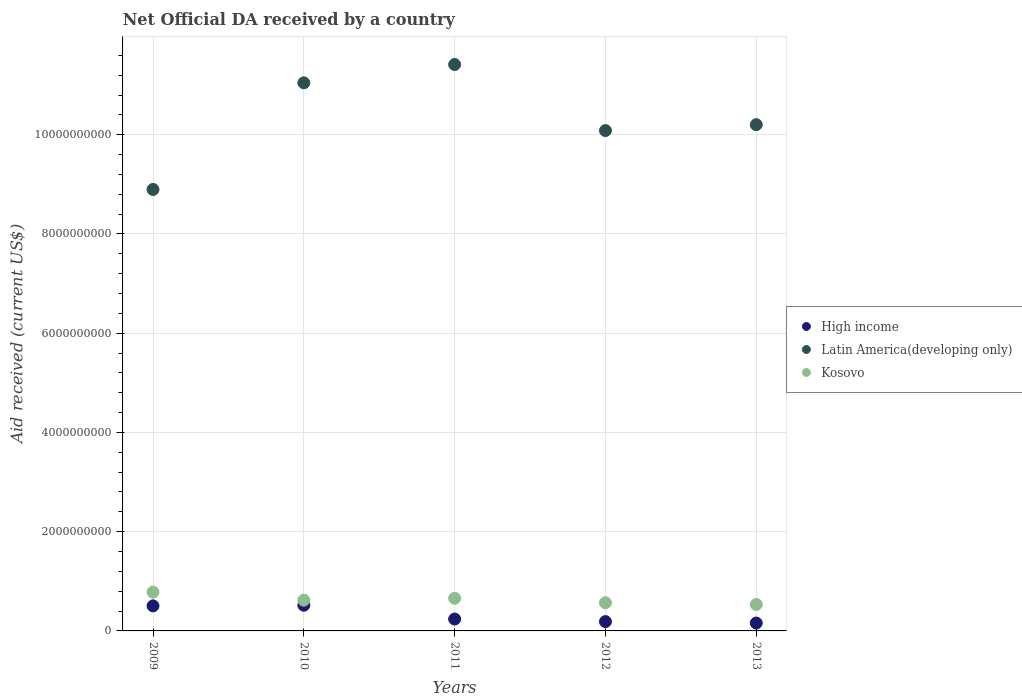Is the number of dotlines equal to the number of legend labels?
Keep it short and to the point. Yes. What is the net official development assistance aid received in Kosovo in 2011?
Provide a short and direct response. 6.57e+08. Across all years, what is the maximum net official development assistance aid received in Kosovo?
Provide a succinct answer. 7.82e+08. Across all years, what is the minimum net official development assistance aid received in High income?
Offer a very short reply. 1.59e+08. In which year was the net official development assistance aid received in Kosovo minimum?
Your response must be concise. 2013. What is the total net official development assistance aid received in Kosovo in the graph?
Ensure brevity in your answer.  3.16e+09. What is the difference between the net official development assistance aid received in High income in 2010 and that in 2013?
Keep it short and to the point. 3.59e+08. What is the difference between the net official development assistance aid received in High income in 2011 and the net official development assistance aid received in Latin America(developing only) in 2013?
Provide a short and direct response. -9.96e+09. What is the average net official development assistance aid received in Latin America(developing only) per year?
Provide a short and direct response. 1.03e+1. In the year 2011, what is the difference between the net official development assistance aid received in Latin America(developing only) and net official development assistance aid received in High income?
Make the answer very short. 1.12e+1. In how many years, is the net official development assistance aid received in High income greater than 5200000000 US$?
Ensure brevity in your answer.  0. What is the ratio of the net official development assistance aid received in Kosovo in 2012 to that in 2013?
Provide a short and direct response. 1.06. Is the difference between the net official development assistance aid received in Latin America(developing only) in 2010 and 2013 greater than the difference between the net official development assistance aid received in High income in 2010 and 2013?
Provide a succinct answer. Yes. What is the difference between the highest and the second highest net official development assistance aid received in Latin America(developing only)?
Give a very brief answer. 3.69e+08. What is the difference between the highest and the lowest net official development assistance aid received in Kosovo?
Ensure brevity in your answer.  2.49e+08. Is the net official development assistance aid received in Kosovo strictly greater than the net official development assistance aid received in High income over the years?
Keep it short and to the point. Yes. Is the net official development assistance aid received in High income strictly less than the net official development assistance aid received in Latin America(developing only) over the years?
Keep it short and to the point. Yes. How many dotlines are there?
Offer a terse response. 3. How many years are there in the graph?
Your answer should be very brief. 5. Are the values on the major ticks of Y-axis written in scientific E-notation?
Provide a succinct answer. No. Does the graph contain any zero values?
Give a very brief answer. No. Does the graph contain grids?
Make the answer very short. Yes. What is the title of the graph?
Provide a short and direct response. Net Official DA received by a country. What is the label or title of the Y-axis?
Your response must be concise. Aid received (current US$). What is the Aid received (current US$) of High income in 2009?
Keep it short and to the point. 5.05e+08. What is the Aid received (current US$) of Latin America(developing only) in 2009?
Your response must be concise. 8.90e+09. What is the Aid received (current US$) of Kosovo in 2009?
Your response must be concise. 7.82e+08. What is the Aid received (current US$) in High income in 2010?
Offer a very short reply. 5.17e+08. What is the Aid received (current US$) in Latin America(developing only) in 2010?
Offer a very short reply. 1.10e+1. What is the Aid received (current US$) of Kosovo in 2010?
Your response must be concise. 6.20e+08. What is the Aid received (current US$) in High income in 2011?
Your answer should be very brief. 2.39e+08. What is the Aid received (current US$) of Latin America(developing only) in 2011?
Keep it short and to the point. 1.14e+1. What is the Aid received (current US$) in Kosovo in 2011?
Your response must be concise. 6.57e+08. What is the Aid received (current US$) in High income in 2012?
Offer a terse response. 1.88e+08. What is the Aid received (current US$) in Latin America(developing only) in 2012?
Ensure brevity in your answer.  1.01e+1. What is the Aid received (current US$) of Kosovo in 2012?
Give a very brief answer. 5.68e+08. What is the Aid received (current US$) of High income in 2013?
Offer a terse response. 1.59e+08. What is the Aid received (current US$) of Latin America(developing only) in 2013?
Offer a very short reply. 1.02e+1. What is the Aid received (current US$) in Kosovo in 2013?
Keep it short and to the point. 5.33e+08. Across all years, what is the maximum Aid received (current US$) of High income?
Your response must be concise. 5.17e+08. Across all years, what is the maximum Aid received (current US$) in Latin America(developing only)?
Provide a short and direct response. 1.14e+1. Across all years, what is the maximum Aid received (current US$) of Kosovo?
Offer a terse response. 7.82e+08. Across all years, what is the minimum Aid received (current US$) in High income?
Provide a short and direct response. 1.59e+08. Across all years, what is the minimum Aid received (current US$) of Latin America(developing only)?
Your answer should be very brief. 8.90e+09. Across all years, what is the minimum Aid received (current US$) in Kosovo?
Keep it short and to the point. 5.33e+08. What is the total Aid received (current US$) of High income in the graph?
Offer a terse response. 1.61e+09. What is the total Aid received (current US$) of Latin America(developing only) in the graph?
Ensure brevity in your answer.  5.16e+1. What is the total Aid received (current US$) of Kosovo in the graph?
Keep it short and to the point. 3.16e+09. What is the difference between the Aid received (current US$) of High income in 2009 and that in 2010?
Your answer should be very brief. -1.27e+07. What is the difference between the Aid received (current US$) of Latin America(developing only) in 2009 and that in 2010?
Give a very brief answer. -2.15e+09. What is the difference between the Aid received (current US$) in Kosovo in 2009 and that in 2010?
Keep it short and to the point. 1.62e+08. What is the difference between the Aid received (current US$) in High income in 2009 and that in 2011?
Your answer should be very brief. 2.65e+08. What is the difference between the Aid received (current US$) of Latin America(developing only) in 2009 and that in 2011?
Offer a terse response. -2.52e+09. What is the difference between the Aid received (current US$) of Kosovo in 2009 and that in 2011?
Your response must be concise. 1.25e+08. What is the difference between the Aid received (current US$) of High income in 2009 and that in 2012?
Keep it short and to the point. 3.17e+08. What is the difference between the Aid received (current US$) of Latin America(developing only) in 2009 and that in 2012?
Your answer should be very brief. -1.19e+09. What is the difference between the Aid received (current US$) of Kosovo in 2009 and that in 2012?
Offer a terse response. 2.14e+08. What is the difference between the Aid received (current US$) in High income in 2009 and that in 2013?
Your response must be concise. 3.46e+08. What is the difference between the Aid received (current US$) of Latin America(developing only) in 2009 and that in 2013?
Offer a terse response. -1.31e+09. What is the difference between the Aid received (current US$) of Kosovo in 2009 and that in 2013?
Ensure brevity in your answer.  2.49e+08. What is the difference between the Aid received (current US$) in High income in 2010 and that in 2011?
Your answer should be very brief. 2.78e+08. What is the difference between the Aid received (current US$) of Latin America(developing only) in 2010 and that in 2011?
Provide a short and direct response. -3.69e+08. What is the difference between the Aid received (current US$) in Kosovo in 2010 and that in 2011?
Keep it short and to the point. -3.72e+07. What is the difference between the Aid received (current US$) of High income in 2010 and that in 2012?
Provide a short and direct response. 3.30e+08. What is the difference between the Aid received (current US$) of Latin America(developing only) in 2010 and that in 2012?
Your response must be concise. 9.62e+08. What is the difference between the Aid received (current US$) of Kosovo in 2010 and that in 2012?
Provide a succinct answer. 5.22e+07. What is the difference between the Aid received (current US$) of High income in 2010 and that in 2013?
Your answer should be compact. 3.59e+08. What is the difference between the Aid received (current US$) in Latin America(developing only) in 2010 and that in 2013?
Your answer should be very brief. 8.44e+08. What is the difference between the Aid received (current US$) of Kosovo in 2010 and that in 2013?
Your answer should be very brief. 8.68e+07. What is the difference between the Aid received (current US$) in High income in 2011 and that in 2012?
Give a very brief answer. 5.17e+07. What is the difference between the Aid received (current US$) of Latin America(developing only) in 2011 and that in 2012?
Give a very brief answer. 1.33e+09. What is the difference between the Aid received (current US$) in Kosovo in 2011 and that in 2012?
Offer a terse response. 8.94e+07. What is the difference between the Aid received (current US$) of High income in 2011 and that in 2013?
Offer a terse response. 8.08e+07. What is the difference between the Aid received (current US$) of Latin America(developing only) in 2011 and that in 2013?
Provide a short and direct response. 1.21e+09. What is the difference between the Aid received (current US$) in Kosovo in 2011 and that in 2013?
Give a very brief answer. 1.24e+08. What is the difference between the Aid received (current US$) in High income in 2012 and that in 2013?
Offer a terse response. 2.91e+07. What is the difference between the Aid received (current US$) of Latin America(developing only) in 2012 and that in 2013?
Make the answer very short. -1.19e+08. What is the difference between the Aid received (current US$) of Kosovo in 2012 and that in 2013?
Your response must be concise. 3.46e+07. What is the difference between the Aid received (current US$) in High income in 2009 and the Aid received (current US$) in Latin America(developing only) in 2010?
Keep it short and to the point. -1.05e+1. What is the difference between the Aid received (current US$) in High income in 2009 and the Aid received (current US$) in Kosovo in 2010?
Provide a succinct answer. -1.15e+08. What is the difference between the Aid received (current US$) of Latin America(developing only) in 2009 and the Aid received (current US$) of Kosovo in 2010?
Keep it short and to the point. 8.28e+09. What is the difference between the Aid received (current US$) in High income in 2009 and the Aid received (current US$) in Latin America(developing only) in 2011?
Give a very brief answer. -1.09e+1. What is the difference between the Aid received (current US$) of High income in 2009 and the Aid received (current US$) of Kosovo in 2011?
Your answer should be compact. -1.53e+08. What is the difference between the Aid received (current US$) of Latin America(developing only) in 2009 and the Aid received (current US$) of Kosovo in 2011?
Your answer should be compact. 8.24e+09. What is the difference between the Aid received (current US$) of High income in 2009 and the Aid received (current US$) of Latin America(developing only) in 2012?
Provide a succinct answer. -9.58e+09. What is the difference between the Aid received (current US$) in High income in 2009 and the Aid received (current US$) in Kosovo in 2012?
Offer a very short reply. -6.32e+07. What is the difference between the Aid received (current US$) in Latin America(developing only) in 2009 and the Aid received (current US$) in Kosovo in 2012?
Provide a succinct answer. 8.33e+09. What is the difference between the Aid received (current US$) of High income in 2009 and the Aid received (current US$) of Latin America(developing only) in 2013?
Keep it short and to the point. -9.70e+09. What is the difference between the Aid received (current US$) in High income in 2009 and the Aid received (current US$) in Kosovo in 2013?
Offer a very short reply. -2.85e+07. What is the difference between the Aid received (current US$) of Latin America(developing only) in 2009 and the Aid received (current US$) of Kosovo in 2013?
Provide a succinct answer. 8.36e+09. What is the difference between the Aid received (current US$) in High income in 2010 and the Aid received (current US$) in Latin America(developing only) in 2011?
Provide a succinct answer. -1.09e+1. What is the difference between the Aid received (current US$) of High income in 2010 and the Aid received (current US$) of Kosovo in 2011?
Ensure brevity in your answer.  -1.40e+08. What is the difference between the Aid received (current US$) of Latin America(developing only) in 2010 and the Aid received (current US$) of Kosovo in 2011?
Ensure brevity in your answer.  1.04e+1. What is the difference between the Aid received (current US$) in High income in 2010 and the Aid received (current US$) in Latin America(developing only) in 2012?
Make the answer very short. -9.57e+09. What is the difference between the Aid received (current US$) in High income in 2010 and the Aid received (current US$) in Kosovo in 2012?
Your response must be concise. -5.05e+07. What is the difference between the Aid received (current US$) in Latin America(developing only) in 2010 and the Aid received (current US$) in Kosovo in 2012?
Keep it short and to the point. 1.05e+1. What is the difference between the Aid received (current US$) of High income in 2010 and the Aid received (current US$) of Latin America(developing only) in 2013?
Provide a succinct answer. -9.69e+09. What is the difference between the Aid received (current US$) in High income in 2010 and the Aid received (current US$) in Kosovo in 2013?
Your answer should be compact. -1.58e+07. What is the difference between the Aid received (current US$) in Latin America(developing only) in 2010 and the Aid received (current US$) in Kosovo in 2013?
Offer a terse response. 1.05e+1. What is the difference between the Aid received (current US$) of High income in 2011 and the Aid received (current US$) of Latin America(developing only) in 2012?
Your answer should be compact. -9.84e+09. What is the difference between the Aid received (current US$) of High income in 2011 and the Aid received (current US$) of Kosovo in 2012?
Provide a succinct answer. -3.28e+08. What is the difference between the Aid received (current US$) of Latin America(developing only) in 2011 and the Aid received (current US$) of Kosovo in 2012?
Your response must be concise. 1.08e+1. What is the difference between the Aid received (current US$) of High income in 2011 and the Aid received (current US$) of Latin America(developing only) in 2013?
Offer a very short reply. -9.96e+09. What is the difference between the Aid received (current US$) of High income in 2011 and the Aid received (current US$) of Kosovo in 2013?
Your answer should be compact. -2.94e+08. What is the difference between the Aid received (current US$) in Latin America(developing only) in 2011 and the Aid received (current US$) in Kosovo in 2013?
Your answer should be compact. 1.09e+1. What is the difference between the Aid received (current US$) in High income in 2012 and the Aid received (current US$) in Latin America(developing only) in 2013?
Your response must be concise. -1.00e+1. What is the difference between the Aid received (current US$) of High income in 2012 and the Aid received (current US$) of Kosovo in 2013?
Your answer should be very brief. -3.45e+08. What is the difference between the Aid received (current US$) in Latin America(developing only) in 2012 and the Aid received (current US$) in Kosovo in 2013?
Offer a very short reply. 9.55e+09. What is the average Aid received (current US$) in High income per year?
Provide a succinct answer. 3.21e+08. What is the average Aid received (current US$) of Latin America(developing only) per year?
Provide a short and direct response. 1.03e+1. What is the average Aid received (current US$) in Kosovo per year?
Give a very brief answer. 6.32e+08. In the year 2009, what is the difference between the Aid received (current US$) of High income and Aid received (current US$) of Latin America(developing only)?
Offer a terse response. -8.39e+09. In the year 2009, what is the difference between the Aid received (current US$) in High income and Aid received (current US$) in Kosovo?
Make the answer very short. -2.78e+08. In the year 2009, what is the difference between the Aid received (current US$) in Latin America(developing only) and Aid received (current US$) in Kosovo?
Your answer should be compact. 8.11e+09. In the year 2010, what is the difference between the Aid received (current US$) of High income and Aid received (current US$) of Latin America(developing only)?
Provide a short and direct response. -1.05e+1. In the year 2010, what is the difference between the Aid received (current US$) of High income and Aid received (current US$) of Kosovo?
Ensure brevity in your answer.  -1.03e+08. In the year 2010, what is the difference between the Aid received (current US$) of Latin America(developing only) and Aid received (current US$) of Kosovo?
Your answer should be very brief. 1.04e+1. In the year 2011, what is the difference between the Aid received (current US$) of High income and Aid received (current US$) of Latin America(developing only)?
Provide a short and direct response. -1.12e+1. In the year 2011, what is the difference between the Aid received (current US$) in High income and Aid received (current US$) in Kosovo?
Your response must be concise. -4.18e+08. In the year 2011, what is the difference between the Aid received (current US$) in Latin America(developing only) and Aid received (current US$) in Kosovo?
Your answer should be compact. 1.08e+1. In the year 2012, what is the difference between the Aid received (current US$) of High income and Aid received (current US$) of Latin America(developing only)?
Your response must be concise. -9.90e+09. In the year 2012, what is the difference between the Aid received (current US$) in High income and Aid received (current US$) in Kosovo?
Offer a very short reply. -3.80e+08. In the year 2012, what is the difference between the Aid received (current US$) in Latin America(developing only) and Aid received (current US$) in Kosovo?
Ensure brevity in your answer.  9.52e+09. In the year 2013, what is the difference between the Aid received (current US$) in High income and Aid received (current US$) in Latin America(developing only)?
Your answer should be very brief. -1.00e+1. In the year 2013, what is the difference between the Aid received (current US$) in High income and Aid received (current US$) in Kosovo?
Keep it short and to the point. -3.74e+08. In the year 2013, what is the difference between the Aid received (current US$) of Latin America(developing only) and Aid received (current US$) of Kosovo?
Give a very brief answer. 9.67e+09. What is the ratio of the Aid received (current US$) in High income in 2009 to that in 2010?
Your response must be concise. 0.98. What is the ratio of the Aid received (current US$) of Latin America(developing only) in 2009 to that in 2010?
Provide a succinct answer. 0.81. What is the ratio of the Aid received (current US$) of Kosovo in 2009 to that in 2010?
Ensure brevity in your answer.  1.26. What is the ratio of the Aid received (current US$) in High income in 2009 to that in 2011?
Offer a terse response. 2.11. What is the ratio of the Aid received (current US$) of Latin America(developing only) in 2009 to that in 2011?
Offer a very short reply. 0.78. What is the ratio of the Aid received (current US$) of Kosovo in 2009 to that in 2011?
Offer a terse response. 1.19. What is the ratio of the Aid received (current US$) of High income in 2009 to that in 2012?
Offer a very short reply. 2.69. What is the ratio of the Aid received (current US$) in Latin America(developing only) in 2009 to that in 2012?
Your answer should be very brief. 0.88. What is the ratio of the Aid received (current US$) in Kosovo in 2009 to that in 2012?
Offer a terse response. 1.38. What is the ratio of the Aid received (current US$) in High income in 2009 to that in 2013?
Your response must be concise. 3.18. What is the ratio of the Aid received (current US$) in Latin America(developing only) in 2009 to that in 2013?
Your response must be concise. 0.87. What is the ratio of the Aid received (current US$) in Kosovo in 2009 to that in 2013?
Make the answer very short. 1.47. What is the ratio of the Aid received (current US$) in High income in 2010 to that in 2011?
Give a very brief answer. 2.16. What is the ratio of the Aid received (current US$) of Latin America(developing only) in 2010 to that in 2011?
Give a very brief answer. 0.97. What is the ratio of the Aid received (current US$) in Kosovo in 2010 to that in 2011?
Your response must be concise. 0.94. What is the ratio of the Aid received (current US$) in High income in 2010 to that in 2012?
Offer a terse response. 2.76. What is the ratio of the Aid received (current US$) of Latin America(developing only) in 2010 to that in 2012?
Your answer should be compact. 1.1. What is the ratio of the Aid received (current US$) of Kosovo in 2010 to that in 2012?
Ensure brevity in your answer.  1.09. What is the ratio of the Aid received (current US$) in High income in 2010 to that in 2013?
Make the answer very short. 3.26. What is the ratio of the Aid received (current US$) of Latin America(developing only) in 2010 to that in 2013?
Offer a terse response. 1.08. What is the ratio of the Aid received (current US$) of Kosovo in 2010 to that in 2013?
Offer a very short reply. 1.16. What is the ratio of the Aid received (current US$) of High income in 2011 to that in 2012?
Make the answer very short. 1.28. What is the ratio of the Aid received (current US$) of Latin America(developing only) in 2011 to that in 2012?
Offer a very short reply. 1.13. What is the ratio of the Aid received (current US$) of Kosovo in 2011 to that in 2012?
Ensure brevity in your answer.  1.16. What is the ratio of the Aid received (current US$) in High income in 2011 to that in 2013?
Give a very brief answer. 1.51. What is the ratio of the Aid received (current US$) in Latin America(developing only) in 2011 to that in 2013?
Give a very brief answer. 1.12. What is the ratio of the Aid received (current US$) in Kosovo in 2011 to that in 2013?
Your answer should be compact. 1.23. What is the ratio of the Aid received (current US$) in High income in 2012 to that in 2013?
Your answer should be compact. 1.18. What is the ratio of the Aid received (current US$) in Latin America(developing only) in 2012 to that in 2013?
Provide a short and direct response. 0.99. What is the ratio of the Aid received (current US$) of Kosovo in 2012 to that in 2013?
Give a very brief answer. 1.06. What is the difference between the highest and the second highest Aid received (current US$) of High income?
Offer a terse response. 1.27e+07. What is the difference between the highest and the second highest Aid received (current US$) in Latin America(developing only)?
Give a very brief answer. 3.69e+08. What is the difference between the highest and the second highest Aid received (current US$) in Kosovo?
Keep it short and to the point. 1.25e+08. What is the difference between the highest and the lowest Aid received (current US$) in High income?
Give a very brief answer. 3.59e+08. What is the difference between the highest and the lowest Aid received (current US$) of Latin America(developing only)?
Keep it short and to the point. 2.52e+09. What is the difference between the highest and the lowest Aid received (current US$) in Kosovo?
Provide a short and direct response. 2.49e+08. 